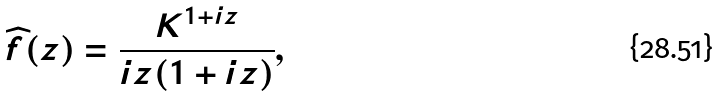Convert formula to latex. <formula><loc_0><loc_0><loc_500><loc_500>\widehat { f } ( z ) = \frac { K ^ { 1 + i z } } { i z ( 1 + i z ) } ,</formula> 